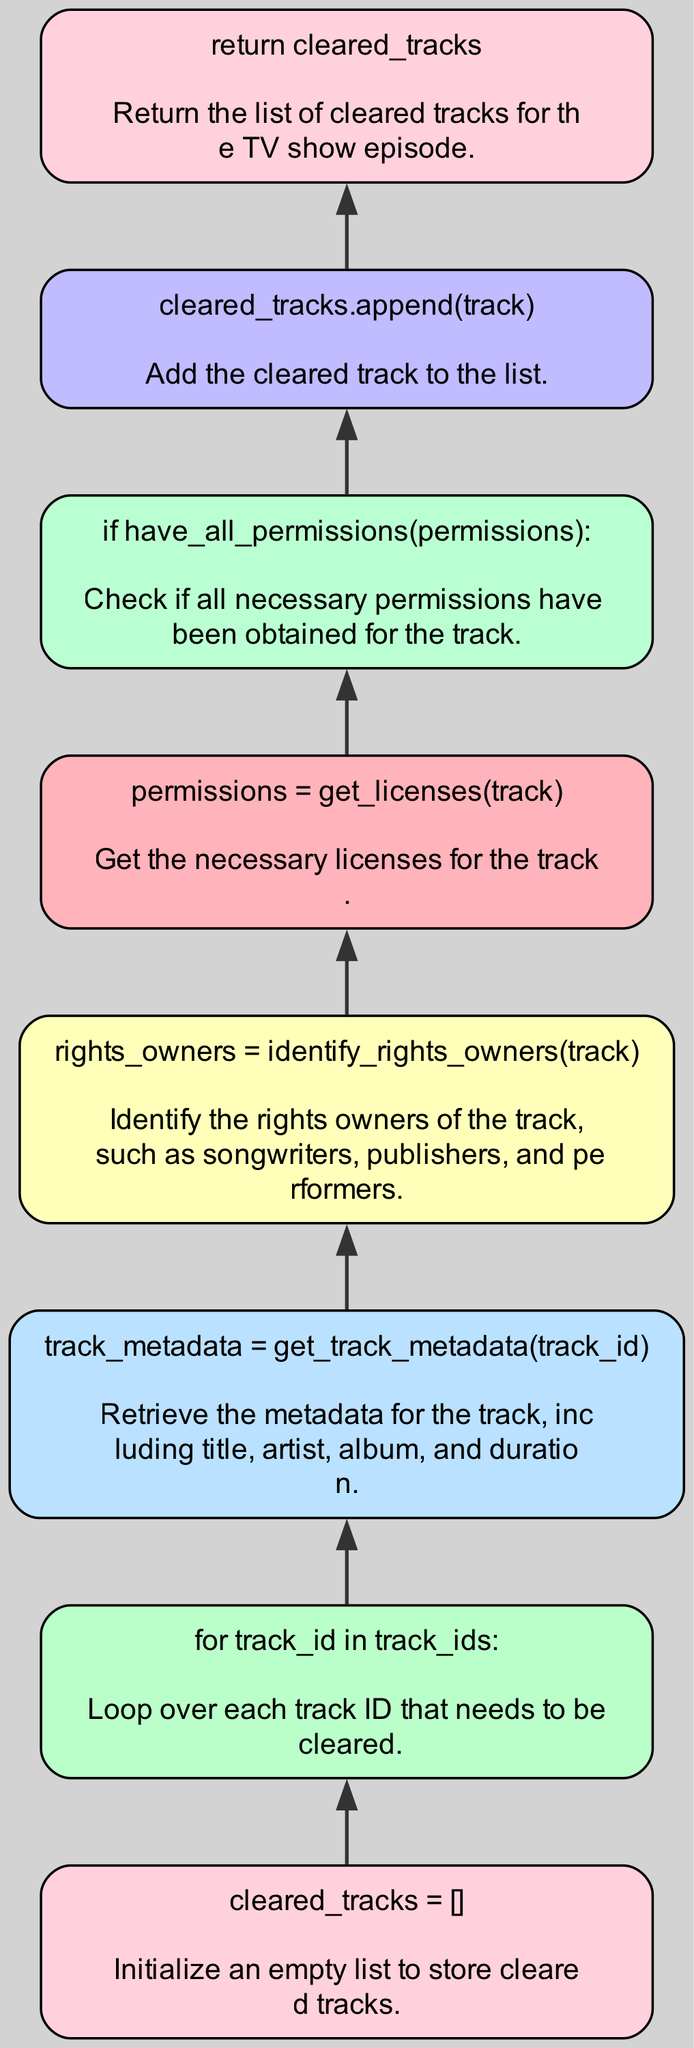What is the first action taken in the flowchart? The flowchart starts with initializing an empty list to store cleared tracks, as indicated by the node labeled "cleared_tracks = []".
Answer: cleared_tracks = [] How many nodes are present in the flowchart? The flowchart contains a total of eight nodes, each representing a specific action or decision in the process of clearing music rights.
Answer: 8 What should be done for each track ID? The flowchart specifies that for each track ID, the necessary steps involving permission checks and metadata retrieval must be carried out, as indicated by the loop "for track_id in track_ids:".
Answer: Loop over each track ID What happens after identifying the rights owners of a track? Once the rights owners are identified, the next step is to retrieve the necessary licenses for the track as shown by the sequence which involves the node "permissions = get_licenses(track)".
Answer: Retrieve licenses What is the output of the function? The output of the function is the return of a list of cleared tracks for the TV show episode, as indicated in the final node "return cleared_tracks".
Answer: Return cleared_tracks What condition needs to be met before appending a track to the cleared list? A track can only be appended to the cleared list if it meets the condition checked by "if have_all_permissions(permissions):", ensuring all necessary permissions are obtained.
Answer: All necessary permissions obtained What is the purpose of getting track metadata? The purpose is to gather essential information about the track such as title, artist, album, and duration, as clarified in the node "track_metadata = get_track_metadata(track_id)".
Answer: Gather essential information What is the last action performed in the flowchart? The last action performed is returning the list of cleared tracks, which concludes the flow chart, represented in the node "return cleared_tracks".
Answer: Return cleared_tracks 